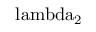<formula> <loc_0><loc_0><loc_500><loc_500>\ l a m b d a _ { 2 }</formula> 